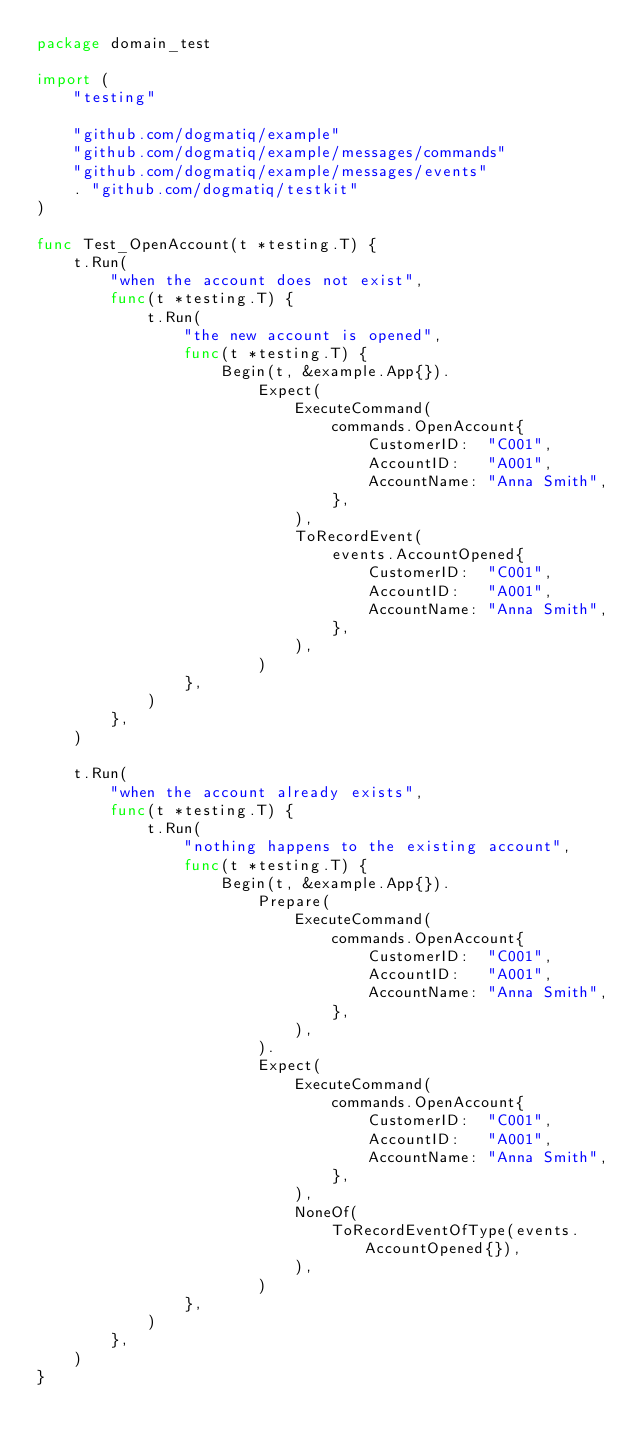<code> <loc_0><loc_0><loc_500><loc_500><_Go_>package domain_test

import (
	"testing"

	"github.com/dogmatiq/example"
	"github.com/dogmatiq/example/messages/commands"
	"github.com/dogmatiq/example/messages/events"
	. "github.com/dogmatiq/testkit"
)

func Test_OpenAccount(t *testing.T) {
	t.Run(
		"when the account does not exist",
		func(t *testing.T) {
			t.Run(
				"the new account is opened",
				func(t *testing.T) {
					Begin(t, &example.App{}).
						Expect(
							ExecuteCommand(
								commands.OpenAccount{
									CustomerID:  "C001",
									AccountID:   "A001",
									AccountName: "Anna Smith",
								},
							),
							ToRecordEvent(
								events.AccountOpened{
									CustomerID:  "C001",
									AccountID:   "A001",
									AccountName: "Anna Smith",
								},
							),
						)
				},
			)
		},
	)

	t.Run(
		"when the account already exists",
		func(t *testing.T) {
			t.Run(
				"nothing happens to the existing account",
				func(t *testing.T) {
					Begin(t, &example.App{}).
						Prepare(
							ExecuteCommand(
								commands.OpenAccount{
									CustomerID:  "C001",
									AccountID:   "A001",
									AccountName: "Anna Smith",
								},
							),
						).
						Expect(
							ExecuteCommand(
								commands.OpenAccount{
									CustomerID:  "C001",
									AccountID:   "A001",
									AccountName: "Anna Smith",
								},
							),
							NoneOf(
								ToRecordEventOfType(events.AccountOpened{}),
							),
						)
				},
			)
		},
	)
}
</code> 